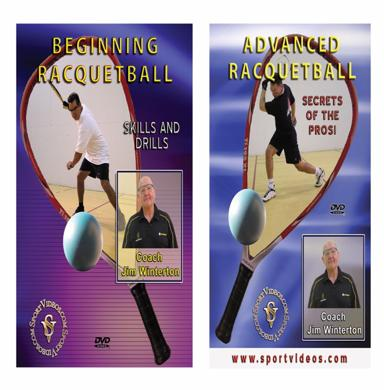What is the image promoting? The image is promoting a series of instructional DVDs on racquetball, specifically designed for different skill levels. The DVDs feature comprehensive training sessions led by the renowned Coach Jim Winterton. It’s an excellent resource for anyone looking to either start learning racquetball with the 'Beginning Racquetball' DVD or enhance existing skills with the 'Advanced Racquetball' DVD, which also includes 'Secrets of the Pros: Skills and Drills'. 